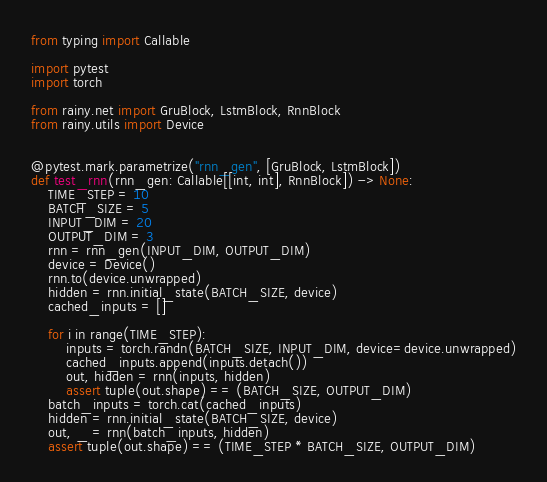<code> <loc_0><loc_0><loc_500><loc_500><_Python_>from typing import Callable

import pytest
import torch

from rainy.net import GruBlock, LstmBlock, RnnBlock
from rainy.utils import Device


@pytest.mark.parametrize("rnn_gen", [GruBlock, LstmBlock])
def test_rnn(rnn_gen: Callable[[int, int], RnnBlock]) -> None:
    TIME_STEP = 10
    BATCH_SIZE = 5
    INPUT_DIM = 20
    OUTPUT_DIM = 3
    rnn = rnn_gen(INPUT_DIM, OUTPUT_DIM)
    device = Device()
    rnn.to(device.unwrapped)
    hidden = rnn.initial_state(BATCH_SIZE, device)
    cached_inputs = []

    for i in range(TIME_STEP):
        inputs = torch.randn(BATCH_SIZE, INPUT_DIM, device=device.unwrapped)
        cached_inputs.append(inputs.detach())
        out, hidden = rnn(inputs, hidden)
        assert tuple(out.shape) == (BATCH_SIZE, OUTPUT_DIM)
    batch_inputs = torch.cat(cached_inputs)
    hidden = rnn.initial_state(BATCH_SIZE, device)
    out, _ = rnn(batch_inputs, hidden)
    assert tuple(out.shape) == (TIME_STEP * BATCH_SIZE, OUTPUT_DIM)
</code> 